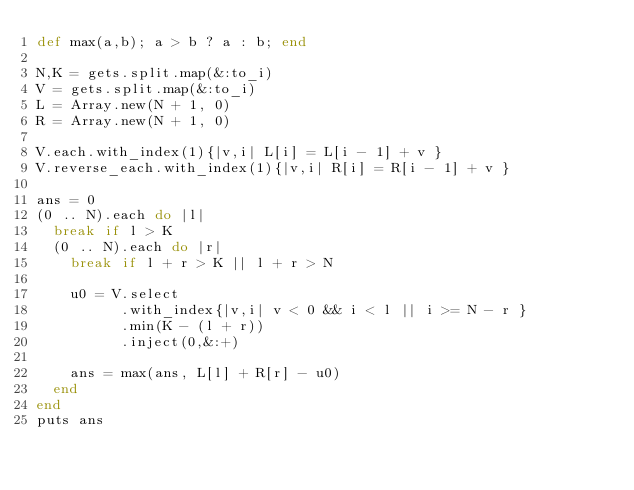Convert code to text. <code><loc_0><loc_0><loc_500><loc_500><_Ruby_>def max(a,b); a > b ? a : b; end
  
N,K = gets.split.map(&:to_i)
V = gets.split.map(&:to_i)
L = Array.new(N + 1, 0)
R = Array.new(N + 1, 0)

V.each.with_index(1){|v,i| L[i] = L[i - 1] + v }
V.reverse_each.with_index(1){|v,i| R[i] = R[i - 1] + v }

ans = 0
(0 .. N).each do |l|
  break if l > K
  (0 .. N).each do |r|
    break if l + r > K || l + r > N
    
    u0 = V.select
          .with_index{|v,i| v < 0 && i < l || i >= N - r }
          .min(K - (l + r))
          .inject(0,&:+)
    
    ans = max(ans, L[l] + R[r] - u0)
  end
end
puts ans</code> 